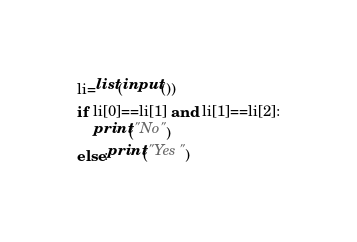<code> <loc_0><loc_0><loc_500><loc_500><_Python_>li=list(input())
if li[0]==li[1] and li[1]==li[2]:
    print("No")
else:print("Yes")</code> 